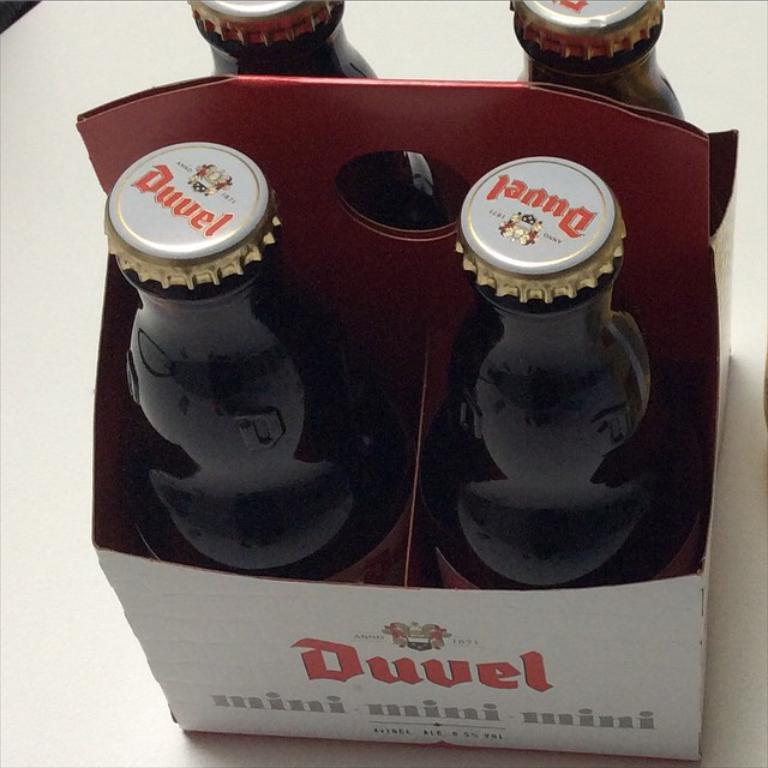Provide a one-sentence caption for the provided image. a close up of a four pack of Duvel drink. 